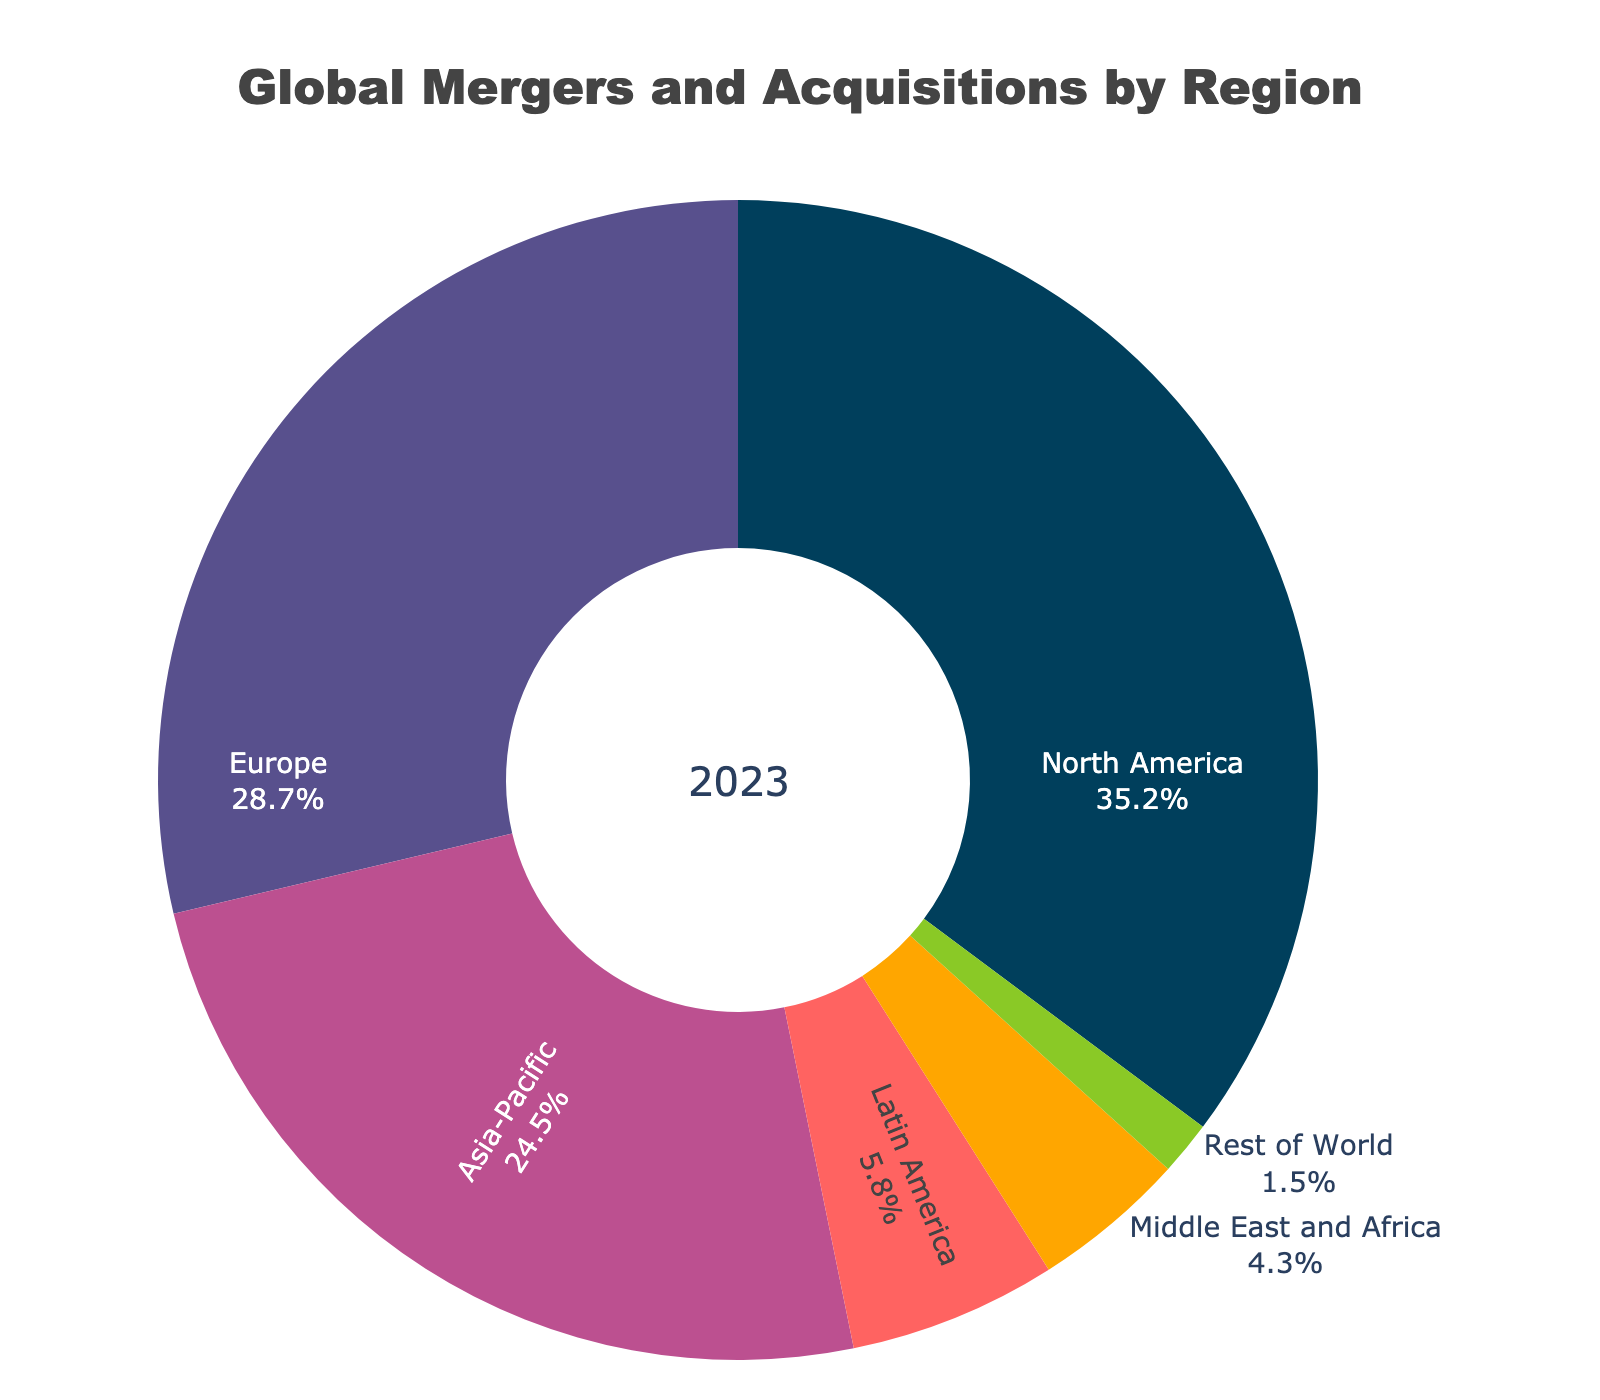What percentage of global mergers and acquisitions is attributed to North America? North America is one of the regions listed in the figure. The value next to it is 35.2%, indicating its percentage.
Answer: 35.2% Which region has the smallest proportion of global mergers and acquisitions? The region with the smallest percentage is the one with the lowest value among all regions listed. "Rest of World" has the smallest value at 1.5%.
Answer: Rest of World How much larger is the percentage of mergers and acquisitions in North America compared to Europe? North America's percentage (35.2%) minus Europe's percentage (28.7%) gives the difference. 35.2 - 28.7 = 6.5.
Answer: 6.5% What's the total percentage of mergers and acquisitions for regions outside North America and Europe? Add Asia-Pacific (24.5%), Latin America (5.8%), Middle East and Africa (4.3%), and Rest of World (1.5%). 24.5 + 5.8 + 4.3 + 1.5 = 36.1.
Answer: 36.1% Which regions have a proportion of mergers and acquisitions below 10%? Latin America (5.8%), Middle East and Africa (4.3%), and Rest of World (1.5%) are all below 10%.
Answer: Latin America, Middle East and Africa, Rest of World What is the combined percentage of mergers and acquisitions for Europe and Asia-Pacific? Sum Europe's percentage (28.7%) and Asia-Pacific's percentage (24.5%). 28.7 + 24.5 = 53.2.
Answer: 53.2% Is the proportion of mergers and acquisitions in Europe greater than that in Asia-Pacific? Compare Europe's percentage (28.7%) with Asia-Pacific’s percentage (24.5%). 28.7 is greater than 24.5.
Answer: Yes What is the percentage difference between Latin America and Middle East and Africa? Subtract Middle East and Africa's percentage (4.3%) from Latin America's percentage (5.8%). 5.8 - 4.3 = 1.5.
Answer: 1.5% What percentage of global mergers and acquisitions do the top three regions contribute? Sum the percentages of North America (35.2%), Europe (28.7%), and Asia-Pacific (24.5%). 35.2 + 28.7 + 24.5 = 88.4.
Answer: 88.4% What is the average percentage of global mergers and acquisitions for all regions? Sum all percentages (35.2 + 28.7 + 24.5 + 5.8 + 4.3 + 1.5) and divide by the number of regions (6). (35.2 + 28.7 + 24.5 + 5.8 + 4.3 + 1.5) / 6 = 100 / 6 ≈ 16.67.
Answer: 16.67% 